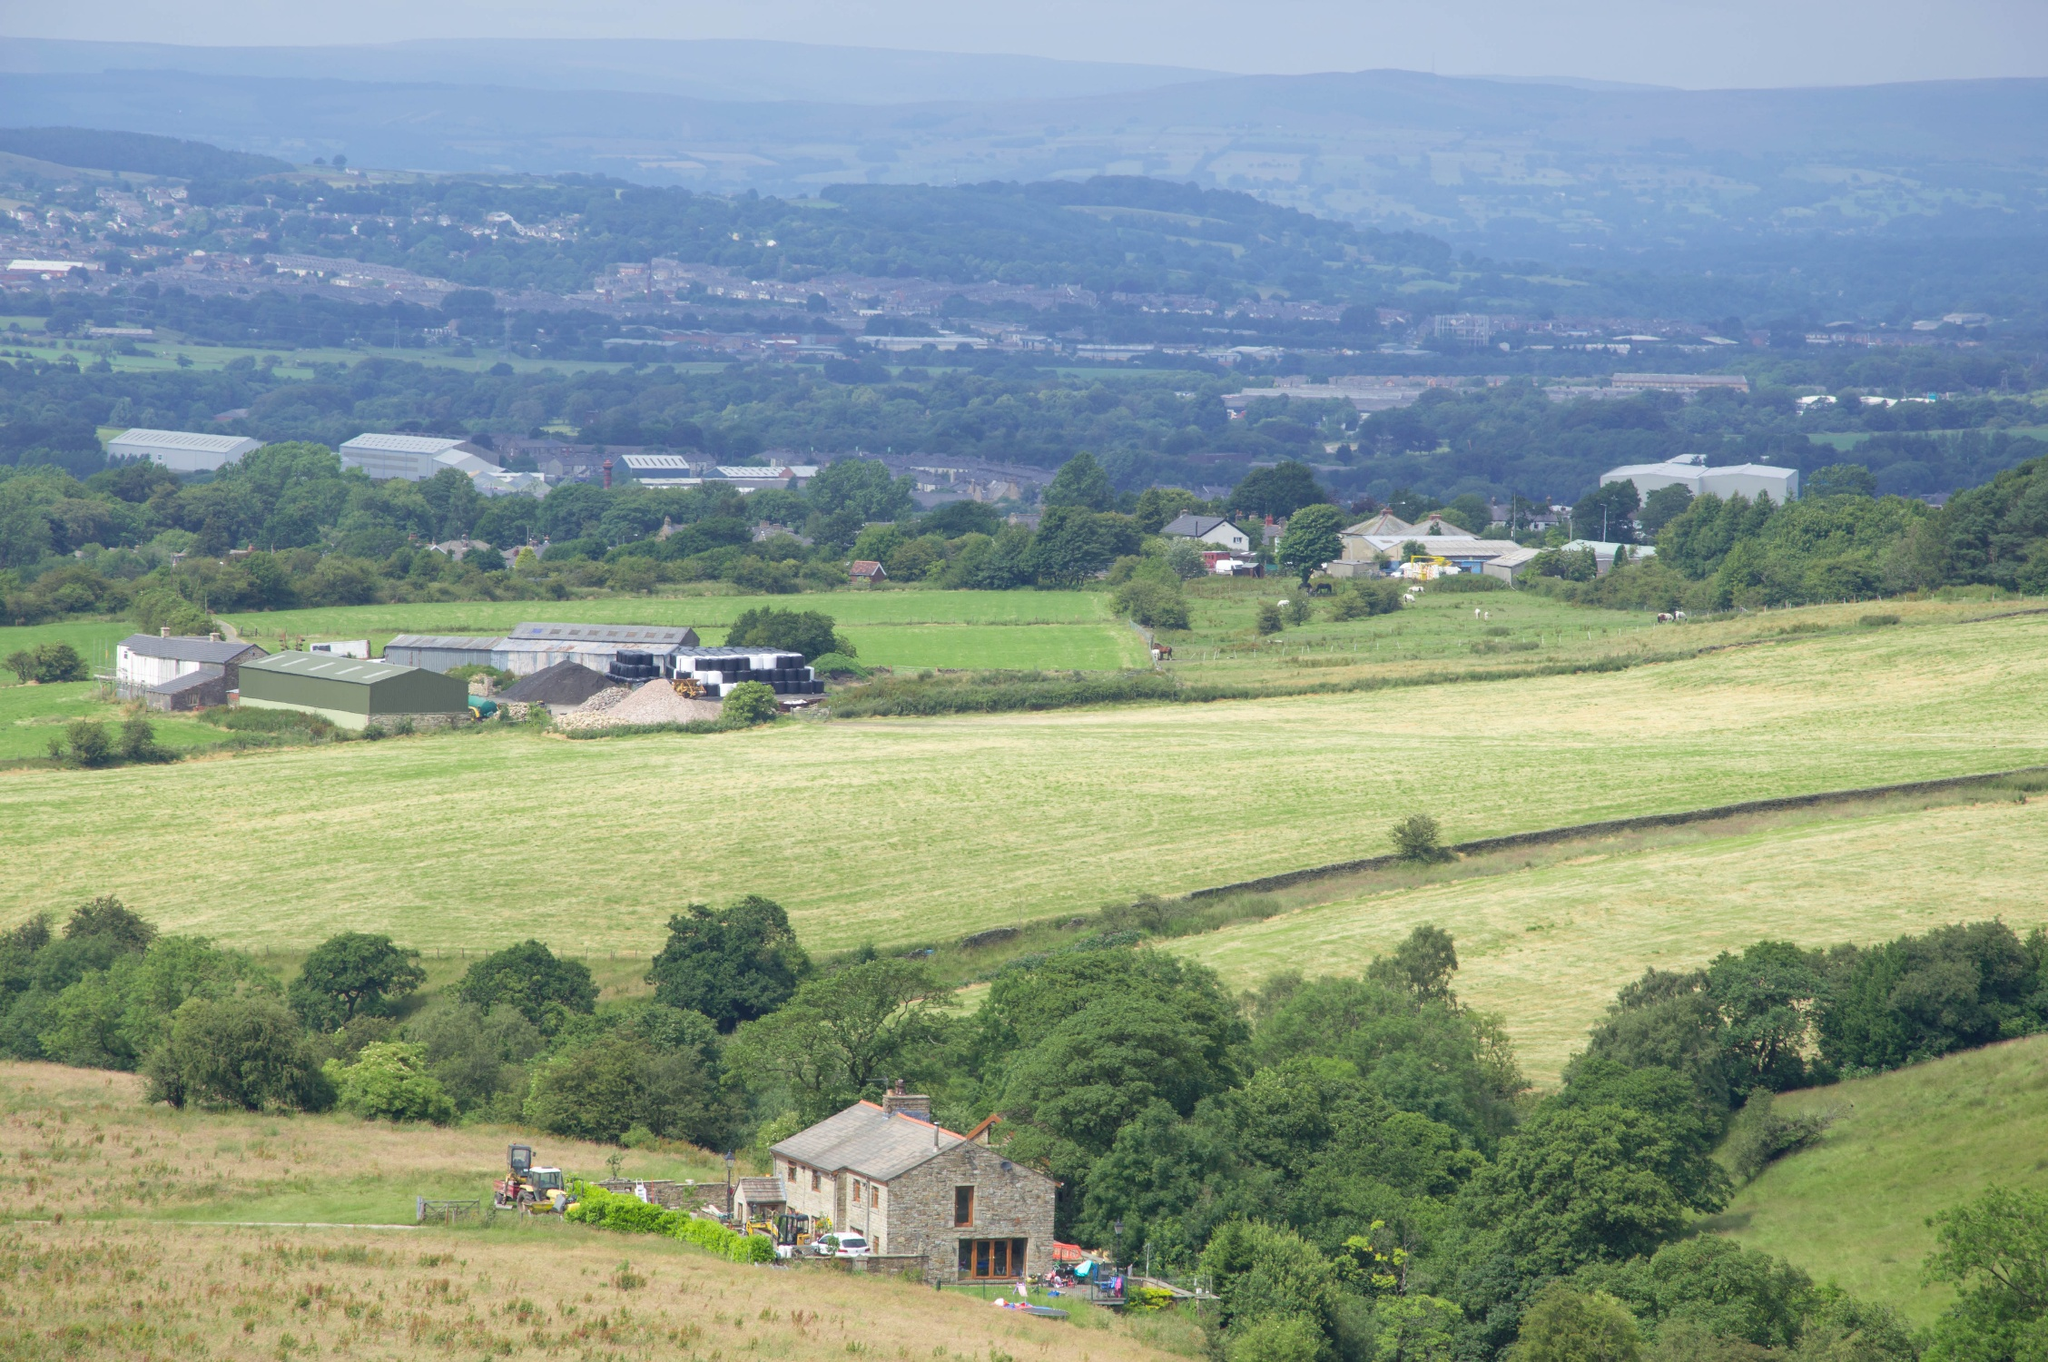Describe the following image.
 This image captures a serene countryside landscape. From a high vantage point, the viewer's gaze is directed towards a small village nestled amidst verdant fields and trees. The village, with its scattering of buildings, appears tranquil and inviting. Surrounding it, the farmland presents a patchwork of green and yellow hues, indicating areas of lush growth and freshly plowed land. The sky above is a soft light blue, dotted with a few clouds, adding to the overall peaceful ambiance of the scene. The perspective from which the photo is taken enhances the vastness of the landscape, while also providing a detailed view of the village and its surroundings. Despite the search results, the specific landmark "sa_16831" could not be identified in the image. 